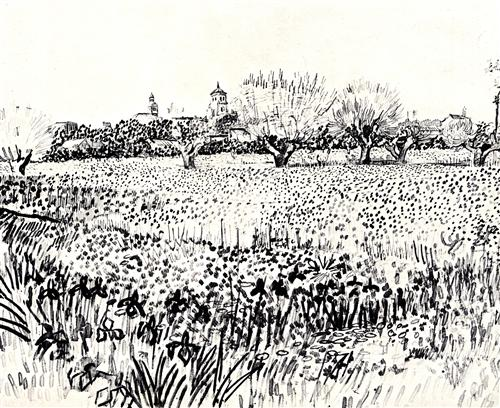Does this scene remind you of any particular moment or memory? This scene reminds me of a spring morning at my grandparents’ countryside home, where the fields would be in full bloom, buzzing with life. It brings back memories of wandering through the tall grasses, the soft rustle under my feet, and the thrill of finding patches of wildflowers I could pick for my grandma. The quietude, interrupted only by the chirping of birds and the distant sounds of village life, always filled me with a sense of calm and contentment, much like this beautiful sketch. 